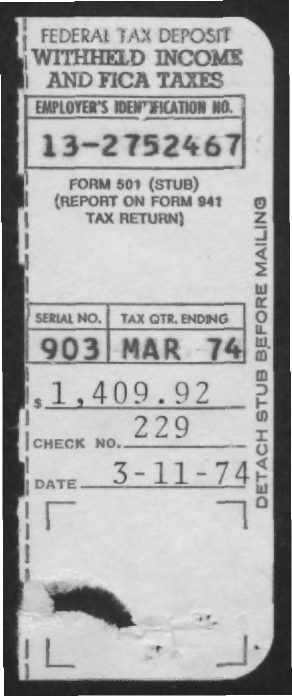Identify some key points in this picture. When was tax paid? On March 11, 1974. The check number is 229. The payment was $1,409.92 in total. 